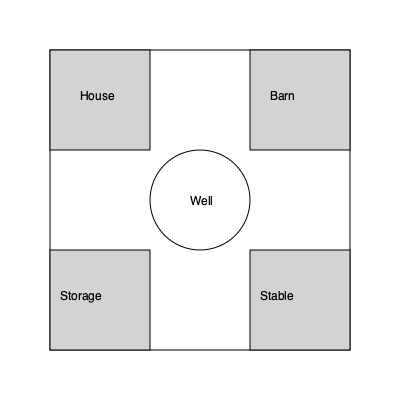In a traditional Lithuanian farmstead layout, if you were to rotate the entire structure 90 degrees clockwise around the central well, which building would now occupy the northwest corner? To solve this spatial reasoning task, let's follow these steps:

1. Identify the current layout:
   - Northwest (top-left): House
   - Northeast (top-right): Barn
   - Southwest (bottom-left): Storage
   - Southeast (bottom-right): Stable
   - Center: Well

2. Understand the rotation:
   - 90 degrees clockwise means each building will move one position clockwise.

3. Visualize the rotation:
   - House moves from northwest to northeast
   - Barn moves from northeast to southeast
   - Stable moves from southeast to southwest
   - Storage moves from southwest to northwest

4. Identify the new northwest corner:
   - After rotation, the Storage building will occupy the northwest corner.

This rotation preserves the traditional layout's symmetry while testing spatial reasoning skills related to Lithuanian farmstead architecture.
Answer: Storage 